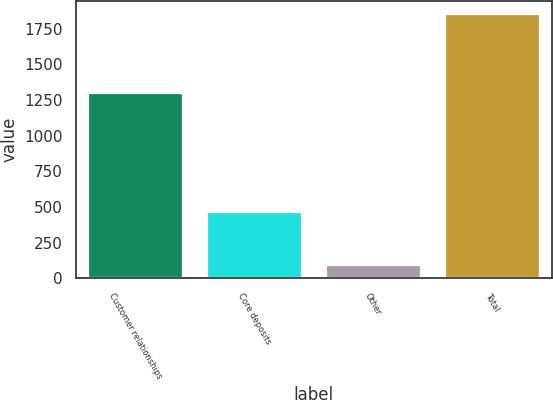<chart> <loc_0><loc_0><loc_500><loc_500><bar_chart><fcel>Customer relationships<fcel>Core deposits<fcel>Other<fcel>Total<nl><fcel>1296<fcel>466<fcel>89<fcel>1851<nl></chart> 